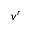Convert formula to latex. <formula><loc_0><loc_0><loc_500><loc_500>v ^ { r }</formula> 